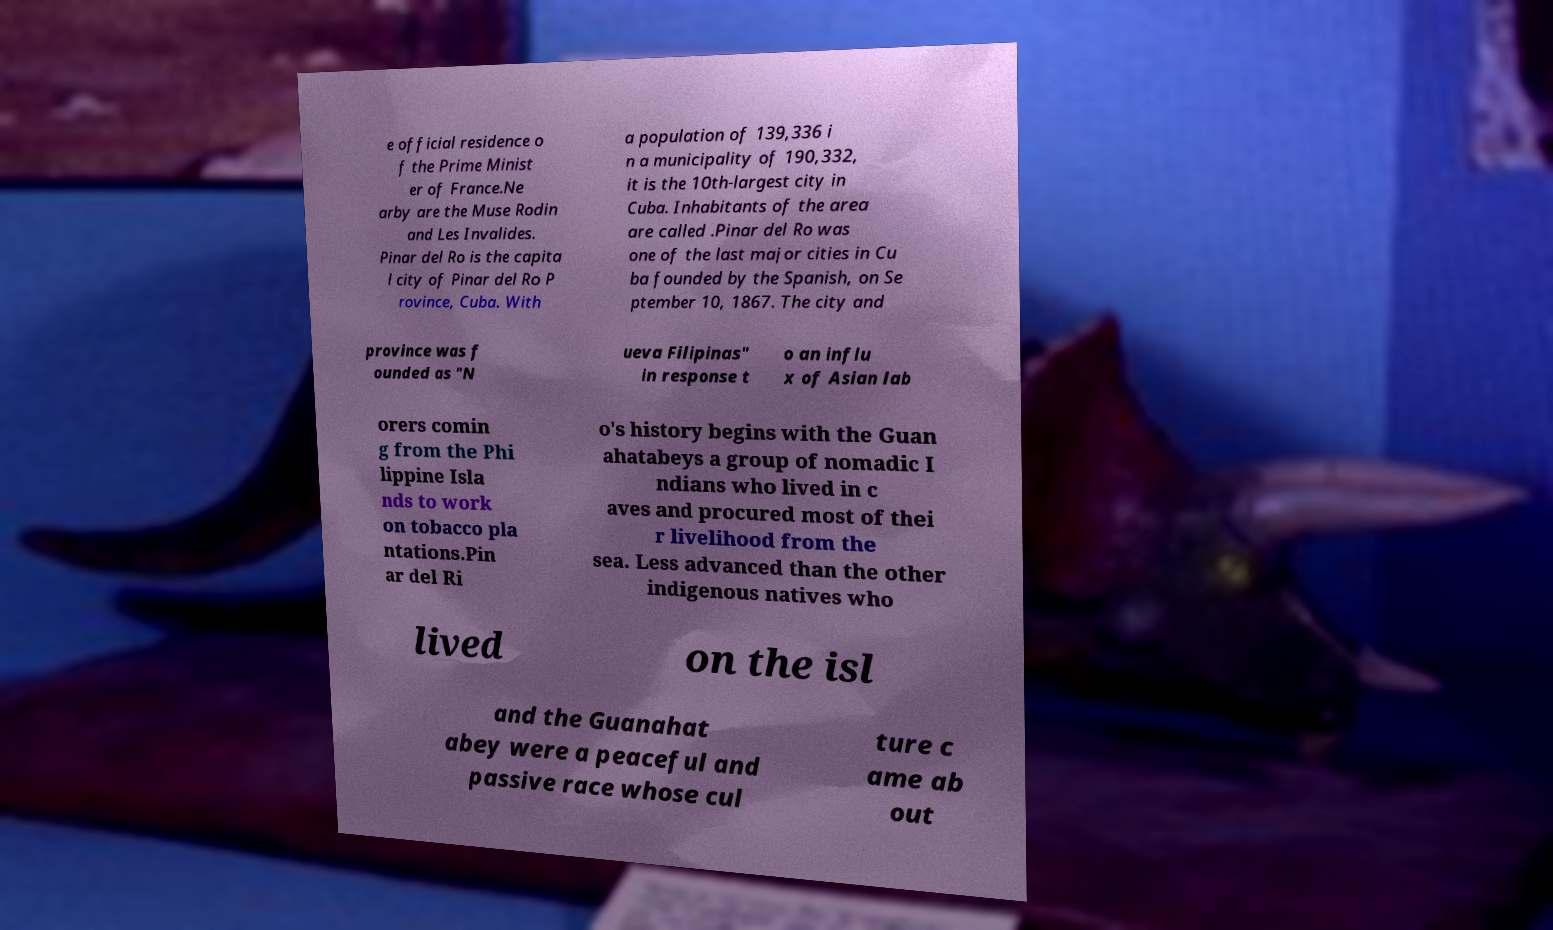I need the written content from this picture converted into text. Can you do that? e official residence o f the Prime Minist er of France.Ne arby are the Muse Rodin and Les Invalides. Pinar del Ro is the capita l city of Pinar del Ro P rovince, Cuba. With a population of 139,336 i n a municipality of 190,332, it is the 10th-largest city in Cuba. Inhabitants of the area are called .Pinar del Ro was one of the last major cities in Cu ba founded by the Spanish, on Se ptember 10, 1867. The city and province was f ounded as "N ueva Filipinas" in response t o an influ x of Asian lab orers comin g from the Phi lippine Isla nds to work on tobacco pla ntations.Pin ar del Ri o's history begins with the Guan ahatabeys a group of nomadic I ndians who lived in c aves and procured most of thei r livelihood from the sea. Less advanced than the other indigenous natives who lived on the isl and the Guanahat abey were a peaceful and passive race whose cul ture c ame ab out 